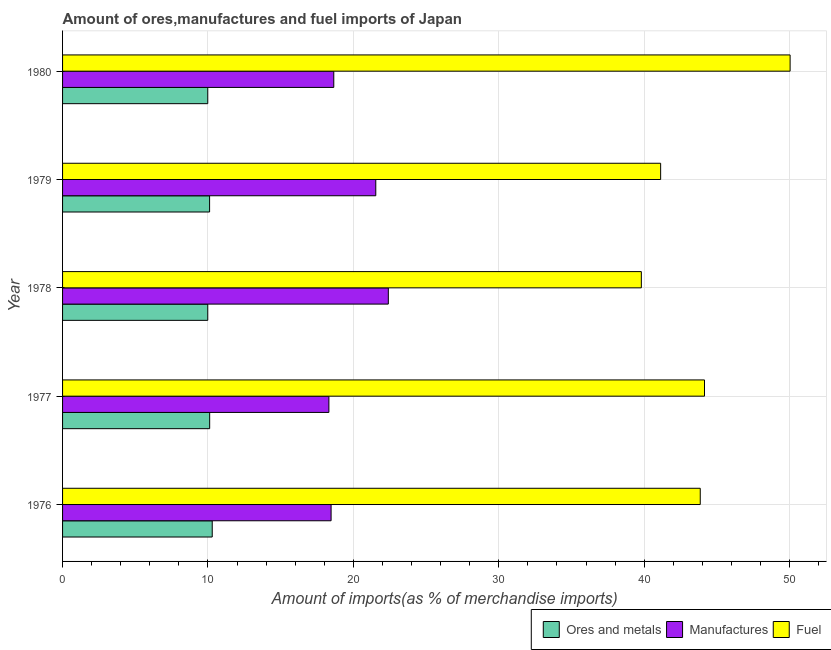How many different coloured bars are there?
Offer a very short reply. 3. Are the number of bars per tick equal to the number of legend labels?
Your response must be concise. Yes. How many bars are there on the 5th tick from the top?
Offer a terse response. 3. In how many cases, is the number of bars for a given year not equal to the number of legend labels?
Make the answer very short. 0. What is the percentage of fuel imports in 1980?
Keep it short and to the point. 50.03. Across all years, what is the maximum percentage of fuel imports?
Ensure brevity in your answer.  50.03. Across all years, what is the minimum percentage of manufactures imports?
Give a very brief answer. 18.32. What is the total percentage of manufactures imports in the graph?
Give a very brief answer. 99.37. What is the difference between the percentage of ores and metals imports in 1976 and that in 1978?
Offer a terse response. 0.31. What is the difference between the percentage of ores and metals imports in 1978 and the percentage of manufactures imports in 1980?
Make the answer very short. -8.67. What is the average percentage of manufactures imports per year?
Your answer should be compact. 19.88. In the year 1978, what is the difference between the percentage of ores and metals imports and percentage of fuel imports?
Ensure brevity in your answer.  -29.82. In how many years, is the percentage of ores and metals imports greater than 16 %?
Provide a short and direct response. 0. What is the ratio of the percentage of ores and metals imports in 1976 to that in 1978?
Offer a terse response. 1.03. Is the percentage of manufactures imports in 1976 less than that in 1980?
Offer a very short reply. Yes. Is the difference between the percentage of fuel imports in 1978 and 1980 greater than the difference between the percentage of ores and metals imports in 1978 and 1980?
Make the answer very short. No. What is the difference between the highest and the second highest percentage of manufactures imports?
Your response must be concise. 0.86. What is the difference between the highest and the lowest percentage of ores and metals imports?
Offer a very short reply. 0.31. What does the 2nd bar from the top in 1977 represents?
Your answer should be very brief. Manufactures. What does the 1st bar from the bottom in 1977 represents?
Your answer should be compact. Ores and metals. How many years are there in the graph?
Your answer should be very brief. 5. Are the values on the major ticks of X-axis written in scientific E-notation?
Offer a very short reply. No. Does the graph contain grids?
Offer a very short reply. Yes. How many legend labels are there?
Keep it short and to the point. 3. What is the title of the graph?
Provide a succinct answer. Amount of ores,manufactures and fuel imports of Japan. What is the label or title of the X-axis?
Provide a short and direct response. Amount of imports(as % of merchandise imports). What is the label or title of the Y-axis?
Provide a short and direct response. Year. What is the Amount of imports(as % of merchandise imports) in Ores and metals in 1976?
Ensure brevity in your answer.  10.29. What is the Amount of imports(as % of merchandise imports) in Manufactures in 1976?
Your answer should be very brief. 18.47. What is the Amount of imports(as % of merchandise imports) of Fuel in 1976?
Ensure brevity in your answer.  43.85. What is the Amount of imports(as % of merchandise imports) of Ores and metals in 1977?
Your answer should be very brief. 10.12. What is the Amount of imports(as % of merchandise imports) of Manufactures in 1977?
Offer a very short reply. 18.32. What is the Amount of imports(as % of merchandise imports) of Fuel in 1977?
Keep it short and to the point. 44.14. What is the Amount of imports(as % of merchandise imports) of Ores and metals in 1978?
Offer a very short reply. 9.99. What is the Amount of imports(as % of merchandise imports) of Manufactures in 1978?
Keep it short and to the point. 22.4. What is the Amount of imports(as % of merchandise imports) of Fuel in 1978?
Give a very brief answer. 39.8. What is the Amount of imports(as % of merchandise imports) of Ores and metals in 1979?
Provide a short and direct response. 10.11. What is the Amount of imports(as % of merchandise imports) of Manufactures in 1979?
Ensure brevity in your answer.  21.54. What is the Amount of imports(as % of merchandise imports) in Fuel in 1979?
Your response must be concise. 41.13. What is the Amount of imports(as % of merchandise imports) of Ores and metals in 1980?
Keep it short and to the point. 9.99. What is the Amount of imports(as % of merchandise imports) of Manufactures in 1980?
Ensure brevity in your answer.  18.65. What is the Amount of imports(as % of merchandise imports) in Fuel in 1980?
Provide a succinct answer. 50.03. Across all years, what is the maximum Amount of imports(as % of merchandise imports) in Ores and metals?
Provide a succinct answer. 10.29. Across all years, what is the maximum Amount of imports(as % of merchandise imports) of Manufactures?
Provide a short and direct response. 22.4. Across all years, what is the maximum Amount of imports(as % of merchandise imports) in Fuel?
Provide a succinct answer. 50.03. Across all years, what is the minimum Amount of imports(as % of merchandise imports) of Ores and metals?
Your answer should be very brief. 9.99. Across all years, what is the minimum Amount of imports(as % of merchandise imports) of Manufactures?
Keep it short and to the point. 18.32. Across all years, what is the minimum Amount of imports(as % of merchandise imports) in Fuel?
Offer a very short reply. 39.8. What is the total Amount of imports(as % of merchandise imports) of Ores and metals in the graph?
Your response must be concise. 50.49. What is the total Amount of imports(as % of merchandise imports) of Manufactures in the graph?
Keep it short and to the point. 99.37. What is the total Amount of imports(as % of merchandise imports) of Fuel in the graph?
Ensure brevity in your answer.  218.96. What is the difference between the Amount of imports(as % of merchandise imports) of Ores and metals in 1976 and that in 1977?
Your answer should be very brief. 0.18. What is the difference between the Amount of imports(as % of merchandise imports) of Manufactures in 1976 and that in 1977?
Offer a terse response. 0.15. What is the difference between the Amount of imports(as % of merchandise imports) in Fuel in 1976 and that in 1977?
Offer a very short reply. -0.29. What is the difference between the Amount of imports(as % of merchandise imports) of Ores and metals in 1976 and that in 1978?
Your response must be concise. 0.31. What is the difference between the Amount of imports(as % of merchandise imports) in Manufactures in 1976 and that in 1978?
Provide a succinct answer. -3.94. What is the difference between the Amount of imports(as % of merchandise imports) of Fuel in 1976 and that in 1978?
Keep it short and to the point. 4.05. What is the difference between the Amount of imports(as % of merchandise imports) in Ores and metals in 1976 and that in 1979?
Offer a very short reply. 0.18. What is the difference between the Amount of imports(as % of merchandise imports) of Manufactures in 1976 and that in 1979?
Offer a very short reply. -3.07. What is the difference between the Amount of imports(as % of merchandise imports) of Fuel in 1976 and that in 1979?
Ensure brevity in your answer.  2.72. What is the difference between the Amount of imports(as % of merchandise imports) in Ores and metals in 1976 and that in 1980?
Your answer should be compact. 0.31. What is the difference between the Amount of imports(as % of merchandise imports) of Manufactures in 1976 and that in 1980?
Offer a terse response. -0.19. What is the difference between the Amount of imports(as % of merchandise imports) in Fuel in 1976 and that in 1980?
Give a very brief answer. -6.18. What is the difference between the Amount of imports(as % of merchandise imports) in Ores and metals in 1977 and that in 1978?
Make the answer very short. 0.13. What is the difference between the Amount of imports(as % of merchandise imports) of Manufactures in 1977 and that in 1978?
Your answer should be compact. -4.09. What is the difference between the Amount of imports(as % of merchandise imports) of Fuel in 1977 and that in 1978?
Make the answer very short. 4.34. What is the difference between the Amount of imports(as % of merchandise imports) of Ores and metals in 1977 and that in 1979?
Keep it short and to the point. 0.01. What is the difference between the Amount of imports(as % of merchandise imports) in Manufactures in 1977 and that in 1979?
Offer a very short reply. -3.22. What is the difference between the Amount of imports(as % of merchandise imports) of Fuel in 1977 and that in 1979?
Provide a succinct answer. 3.02. What is the difference between the Amount of imports(as % of merchandise imports) of Ores and metals in 1977 and that in 1980?
Your response must be concise. 0.13. What is the difference between the Amount of imports(as % of merchandise imports) of Manufactures in 1977 and that in 1980?
Make the answer very short. -0.34. What is the difference between the Amount of imports(as % of merchandise imports) in Fuel in 1977 and that in 1980?
Provide a succinct answer. -5.89. What is the difference between the Amount of imports(as % of merchandise imports) of Ores and metals in 1978 and that in 1979?
Keep it short and to the point. -0.13. What is the difference between the Amount of imports(as % of merchandise imports) in Manufactures in 1978 and that in 1979?
Provide a succinct answer. 0.86. What is the difference between the Amount of imports(as % of merchandise imports) in Fuel in 1978 and that in 1979?
Provide a succinct answer. -1.33. What is the difference between the Amount of imports(as % of merchandise imports) in Manufactures in 1978 and that in 1980?
Keep it short and to the point. 3.75. What is the difference between the Amount of imports(as % of merchandise imports) in Fuel in 1978 and that in 1980?
Your answer should be very brief. -10.23. What is the difference between the Amount of imports(as % of merchandise imports) in Ores and metals in 1979 and that in 1980?
Provide a short and direct response. 0.13. What is the difference between the Amount of imports(as % of merchandise imports) in Manufactures in 1979 and that in 1980?
Your answer should be very brief. 2.89. What is the difference between the Amount of imports(as % of merchandise imports) of Fuel in 1979 and that in 1980?
Keep it short and to the point. -8.9. What is the difference between the Amount of imports(as % of merchandise imports) in Ores and metals in 1976 and the Amount of imports(as % of merchandise imports) in Manufactures in 1977?
Keep it short and to the point. -8.02. What is the difference between the Amount of imports(as % of merchandise imports) of Ores and metals in 1976 and the Amount of imports(as % of merchandise imports) of Fuel in 1977?
Your answer should be very brief. -33.85. What is the difference between the Amount of imports(as % of merchandise imports) in Manufactures in 1976 and the Amount of imports(as % of merchandise imports) in Fuel in 1977?
Ensure brevity in your answer.  -25.68. What is the difference between the Amount of imports(as % of merchandise imports) of Ores and metals in 1976 and the Amount of imports(as % of merchandise imports) of Manufactures in 1978?
Make the answer very short. -12.11. What is the difference between the Amount of imports(as % of merchandise imports) in Ores and metals in 1976 and the Amount of imports(as % of merchandise imports) in Fuel in 1978?
Provide a succinct answer. -29.51. What is the difference between the Amount of imports(as % of merchandise imports) of Manufactures in 1976 and the Amount of imports(as % of merchandise imports) of Fuel in 1978?
Provide a short and direct response. -21.34. What is the difference between the Amount of imports(as % of merchandise imports) in Ores and metals in 1976 and the Amount of imports(as % of merchandise imports) in Manufactures in 1979?
Ensure brevity in your answer.  -11.25. What is the difference between the Amount of imports(as % of merchandise imports) of Ores and metals in 1976 and the Amount of imports(as % of merchandise imports) of Fuel in 1979?
Provide a short and direct response. -30.84. What is the difference between the Amount of imports(as % of merchandise imports) of Manufactures in 1976 and the Amount of imports(as % of merchandise imports) of Fuel in 1979?
Ensure brevity in your answer.  -22.66. What is the difference between the Amount of imports(as % of merchandise imports) of Ores and metals in 1976 and the Amount of imports(as % of merchandise imports) of Manufactures in 1980?
Provide a succinct answer. -8.36. What is the difference between the Amount of imports(as % of merchandise imports) of Ores and metals in 1976 and the Amount of imports(as % of merchandise imports) of Fuel in 1980?
Provide a short and direct response. -39.74. What is the difference between the Amount of imports(as % of merchandise imports) of Manufactures in 1976 and the Amount of imports(as % of merchandise imports) of Fuel in 1980?
Make the answer very short. -31.57. What is the difference between the Amount of imports(as % of merchandise imports) in Ores and metals in 1977 and the Amount of imports(as % of merchandise imports) in Manufactures in 1978?
Provide a succinct answer. -12.29. What is the difference between the Amount of imports(as % of merchandise imports) in Ores and metals in 1977 and the Amount of imports(as % of merchandise imports) in Fuel in 1978?
Ensure brevity in your answer.  -29.68. What is the difference between the Amount of imports(as % of merchandise imports) in Manufactures in 1977 and the Amount of imports(as % of merchandise imports) in Fuel in 1978?
Provide a succinct answer. -21.49. What is the difference between the Amount of imports(as % of merchandise imports) of Ores and metals in 1977 and the Amount of imports(as % of merchandise imports) of Manufactures in 1979?
Your answer should be compact. -11.42. What is the difference between the Amount of imports(as % of merchandise imports) in Ores and metals in 1977 and the Amount of imports(as % of merchandise imports) in Fuel in 1979?
Your answer should be very brief. -31.01. What is the difference between the Amount of imports(as % of merchandise imports) of Manufactures in 1977 and the Amount of imports(as % of merchandise imports) of Fuel in 1979?
Give a very brief answer. -22.81. What is the difference between the Amount of imports(as % of merchandise imports) of Ores and metals in 1977 and the Amount of imports(as % of merchandise imports) of Manufactures in 1980?
Your response must be concise. -8.53. What is the difference between the Amount of imports(as % of merchandise imports) of Ores and metals in 1977 and the Amount of imports(as % of merchandise imports) of Fuel in 1980?
Offer a very short reply. -39.92. What is the difference between the Amount of imports(as % of merchandise imports) of Manufactures in 1977 and the Amount of imports(as % of merchandise imports) of Fuel in 1980?
Offer a very short reply. -31.72. What is the difference between the Amount of imports(as % of merchandise imports) of Ores and metals in 1978 and the Amount of imports(as % of merchandise imports) of Manufactures in 1979?
Keep it short and to the point. -11.55. What is the difference between the Amount of imports(as % of merchandise imports) in Ores and metals in 1978 and the Amount of imports(as % of merchandise imports) in Fuel in 1979?
Your answer should be very brief. -31.14. What is the difference between the Amount of imports(as % of merchandise imports) of Manufactures in 1978 and the Amount of imports(as % of merchandise imports) of Fuel in 1979?
Keep it short and to the point. -18.73. What is the difference between the Amount of imports(as % of merchandise imports) of Ores and metals in 1978 and the Amount of imports(as % of merchandise imports) of Manufactures in 1980?
Offer a terse response. -8.67. What is the difference between the Amount of imports(as % of merchandise imports) of Ores and metals in 1978 and the Amount of imports(as % of merchandise imports) of Fuel in 1980?
Offer a very short reply. -40.05. What is the difference between the Amount of imports(as % of merchandise imports) in Manufactures in 1978 and the Amount of imports(as % of merchandise imports) in Fuel in 1980?
Provide a short and direct response. -27.63. What is the difference between the Amount of imports(as % of merchandise imports) in Ores and metals in 1979 and the Amount of imports(as % of merchandise imports) in Manufactures in 1980?
Keep it short and to the point. -8.54. What is the difference between the Amount of imports(as % of merchandise imports) of Ores and metals in 1979 and the Amount of imports(as % of merchandise imports) of Fuel in 1980?
Ensure brevity in your answer.  -39.92. What is the difference between the Amount of imports(as % of merchandise imports) in Manufactures in 1979 and the Amount of imports(as % of merchandise imports) in Fuel in 1980?
Make the answer very short. -28.49. What is the average Amount of imports(as % of merchandise imports) of Ores and metals per year?
Offer a very short reply. 10.1. What is the average Amount of imports(as % of merchandise imports) in Manufactures per year?
Give a very brief answer. 19.87. What is the average Amount of imports(as % of merchandise imports) of Fuel per year?
Offer a very short reply. 43.79. In the year 1976, what is the difference between the Amount of imports(as % of merchandise imports) of Ores and metals and Amount of imports(as % of merchandise imports) of Manufactures?
Provide a short and direct response. -8.17. In the year 1976, what is the difference between the Amount of imports(as % of merchandise imports) in Ores and metals and Amount of imports(as % of merchandise imports) in Fuel?
Provide a succinct answer. -33.56. In the year 1976, what is the difference between the Amount of imports(as % of merchandise imports) in Manufactures and Amount of imports(as % of merchandise imports) in Fuel?
Provide a short and direct response. -25.39. In the year 1977, what is the difference between the Amount of imports(as % of merchandise imports) of Ores and metals and Amount of imports(as % of merchandise imports) of Manufactures?
Provide a succinct answer. -8.2. In the year 1977, what is the difference between the Amount of imports(as % of merchandise imports) in Ores and metals and Amount of imports(as % of merchandise imports) in Fuel?
Ensure brevity in your answer.  -34.03. In the year 1977, what is the difference between the Amount of imports(as % of merchandise imports) in Manufactures and Amount of imports(as % of merchandise imports) in Fuel?
Offer a very short reply. -25.83. In the year 1978, what is the difference between the Amount of imports(as % of merchandise imports) of Ores and metals and Amount of imports(as % of merchandise imports) of Manufactures?
Offer a very short reply. -12.42. In the year 1978, what is the difference between the Amount of imports(as % of merchandise imports) in Ores and metals and Amount of imports(as % of merchandise imports) in Fuel?
Make the answer very short. -29.82. In the year 1978, what is the difference between the Amount of imports(as % of merchandise imports) of Manufactures and Amount of imports(as % of merchandise imports) of Fuel?
Make the answer very short. -17.4. In the year 1979, what is the difference between the Amount of imports(as % of merchandise imports) in Ores and metals and Amount of imports(as % of merchandise imports) in Manufactures?
Provide a succinct answer. -11.43. In the year 1979, what is the difference between the Amount of imports(as % of merchandise imports) in Ores and metals and Amount of imports(as % of merchandise imports) in Fuel?
Offer a terse response. -31.02. In the year 1979, what is the difference between the Amount of imports(as % of merchandise imports) of Manufactures and Amount of imports(as % of merchandise imports) of Fuel?
Your answer should be very brief. -19.59. In the year 1980, what is the difference between the Amount of imports(as % of merchandise imports) in Ores and metals and Amount of imports(as % of merchandise imports) in Manufactures?
Your answer should be very brief. -8.67. In the year 1980, what is the difference between the Amount of imports(as % of merchandise imports) of Ores and metals and Amount of imports(as % of merchandise imports) of Fuel?
Your answer should be compact. -40.05. In the year 1980, what is the difference between the Amount of imports(as % of merchandise imports) in Manufactures and Amount of imports(as % of merchandise imports) in Fuel?
Offer a very short reply. -31.38. What is the ratio of the Amount of imports(as % of merchandise imports) in Ores and metals in 1976 to that in 1977?
Ensure brevity in your answer.  1.02. What is the ratio of the Amount of imports(as % of merchandise imports) in Manufactures in 1976 to that in 1977?
Keep it short and to the point. 1.01. What is the ratio of the Amount of imports(as % of merchandise imports) of Ores and metals in 1976 to that in 1978?
Give a very brief answer. 1.03. What is the ratio of the Amount of imports(as % of merchandise imports) of Manufactures in 1976 to that in 1978?
Offer a very short reply. 0.82. What is the ratio of the Amount of imports(as % of merchandise imports) of Fuel in 1976 to that in 1978?
Provide a succinct answer. 1.1. What is the ratio of the Amount of imports(as % of merchandise imports) of Manufactures in 1976 to that in 1979?
Provide a short and direct response. 0.86. What is the ratio of the Amount of imports(as % of merchandise imports) in Fuel in 1976 to that in 1979?
Provide a short and direct response. 1.07. What is the ratio of the Amount of imports(as % of merchandise imports) in Ores and metals in 1976 to that in 1980?
Your answer should be very brief. 1.03. What is the ratio of the Amount of imports(as % of merchandise imports) in Manufactures in 1976 to that in 1980?
Ensure brevity in your answer.  0.99. What is the ratio of the Amount of imports(as % of merchandise imports) of Fuel in 1976 to that in 1980?
Make the answer very short. 0.88. What is the ratio of the Amount of imports(as % of merchandise imports) in Ores and metals in 1977 to that in 1978?
Keep it short and to the point. 1.01. What is the ratio of the Amount of imports(as % of merchandise imports) of Manufactures in 1977 to that in 1978?
Give a very brief answer. 0.82. What is the ratio of the Amount of imports(as % of merchandise imports) of Fuel in 1977 to that in 1978?
Your answer should be very brief. 1.11. What is the ratio of the Amount of imports(as % of merchandise imports) in Ores and metals in 1977 to that in 1979?
Your response must be concise. 1. What is the ratio of the Amount of imports(as % of merchandise imports) in Manufactures in 1977 to that in 1979?
Keep it short and to the point. 0.85. What is the ratio of the Amount of imports(as % of merchandise imports) in Fuel in 1977 to that in 1979?
Ensure brevity in your answer.  1.07. What is the ratio of the Amount of imports(as % of merchandise imports) of Ores and metals in 1977 to that in 1980?
Give a very brief answer. 1.01. What is the ratio of the Amount of imports(as % of merchandise imports) of Manufactures in 1977 to that in 1980?
Give a very brief answer. 0.98. What is the ratio of the Amount of imports(as % of merchandise imports) in Fuel in 1977 to that in 1980?
Provide a short and direct response. 0.88. What is the ratio of the Amount of imports(as % of merchandise imports) of Ores and metals in 1978 to that in 1979?
Your response must be concise. 0.99. What is the ratio of the Amount of imports(as % of merchandise imports) of Manufactures in 1978 to that in 1979?
Provide a succinct answer. 1.04. What is the ratio of the Amount of imports(as % of merchandise imports) in Fuel in 1978 to that in 1979?
Ensure brevity in your answer.  0.97. What is the ratio of the Amount of imports(as % of merchandise imports) in Manufactures in 1978 to that in 1980?
Provide a short and direct response. 1.2. What is the ratio of the Amount of imports(as % of merchandise imports) of Fuel in 1978 to that in 1980?
Offer a very short reply. 0.8. What is the ratio of the Amount of imports(as % of merchandise imports) in Ores and metals in 1979 to that in 1980?
Provide a succinct answer. 1.01. What is the ratio of the Amount of imports(as % of merchandise imports) in Manufactures in 1979 to that in 1980?
Keep it short and to the point. 1.15. What is the ratio of the Amount of imports(as % of merchandise imports) in Fuel in 1979 to that in 1980?
Ensure brevity in your answer.  0.82. What is the difference between the highest and the second highest Amount of imports(as % of merchandise imports) in Ores and metals?
Your response must be concise. 0.18. What is the difference between the highest and the second highest Amount of imports(as % of merchandise imports) of Manufactures?
Ensure brevity in your answer.  0.86. What is the difference between the highest and the second highest Amount of imports(as % of merchandise imports) in Fuel?
Your answer should be very brief. 5.89. What is the difference between the highest and the lowest Amount of imports(as % of merchandise imports) in Ores and metals?
Offer a very short reply. 0.31. What is the difference between the highest and the lowest Amount of imports(as % of merchandise imports) of Manufactures?
Make the answer very short. 4.09. What is the difference between the highest and the lowest Amount of imports(as % of merchandise imports) in Fuel?
Make the answer very short. 10.23. 